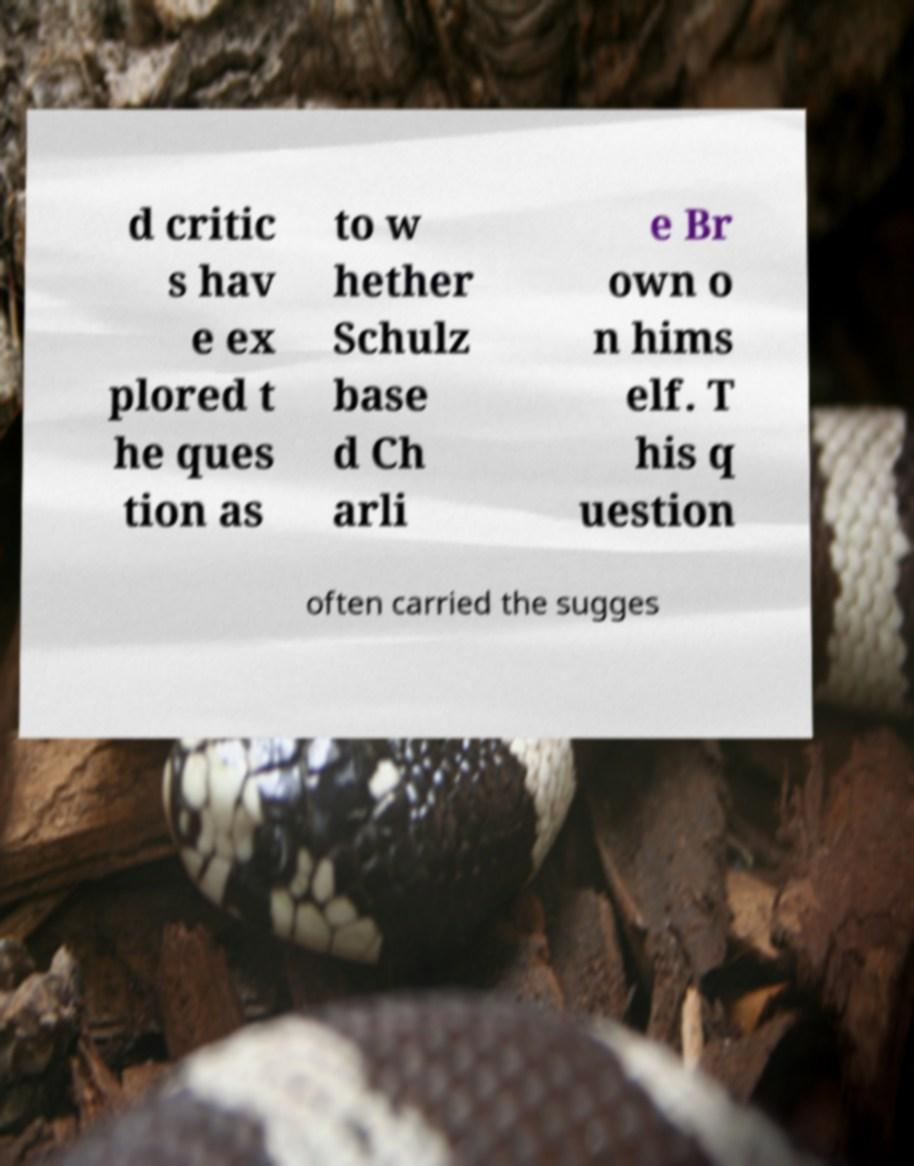For documentation purposes, I need the text within this image transcribed. Could you provide that? d critic s hav e ex plored t he ques tion as to w hether Schulz base d Ch arli e Br own o n hims elf. T his q uestion often carried the sugges 